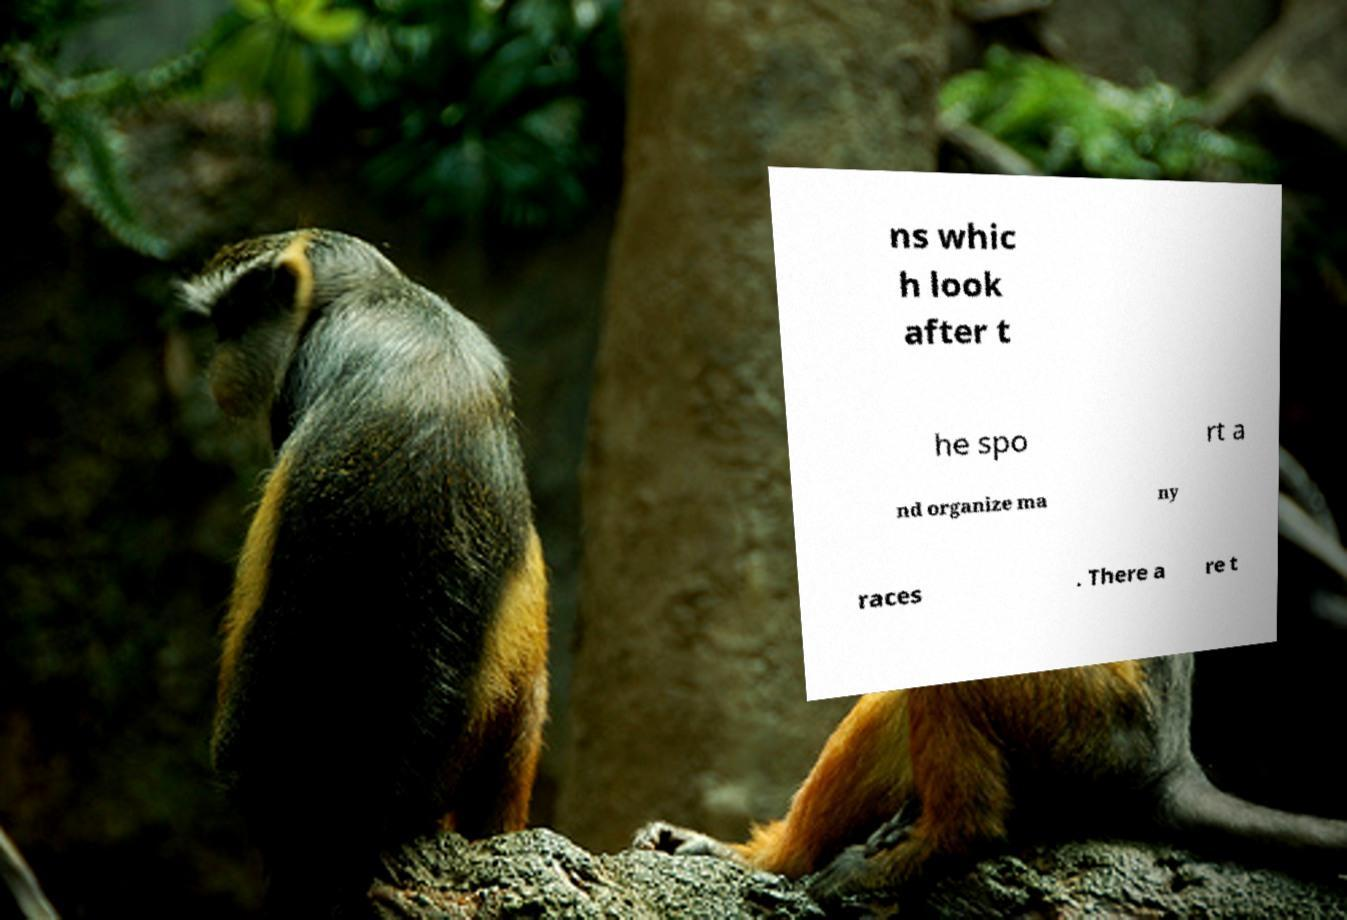Could you extract and type out the text from this image? ns whic h look after t he spo rt a nd organize ma ny races . There a re t 